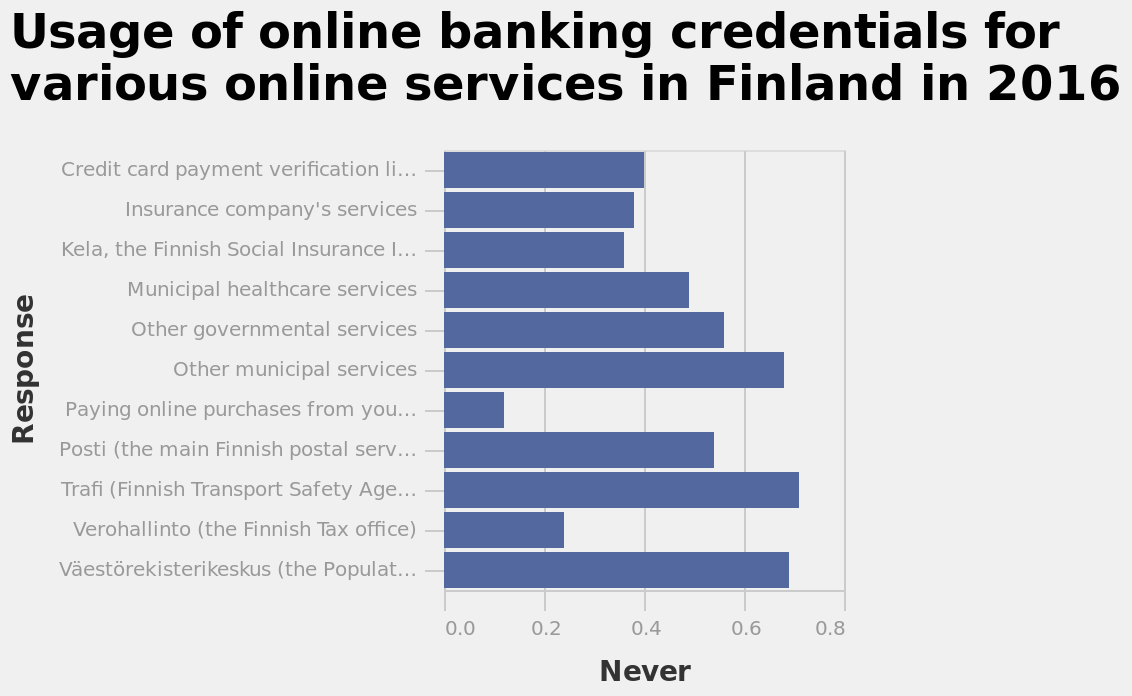<image>
Why are government run services asking for credit card credentials more frequently? The reason for government run services asking for credit card credentials more frequently is not mentioned in the description. What is the label on the x-axis? The label on the x-axis is "Never". Offer a thorough analysis of the image. Government run services seems to ask for credit card credentials more frequently. 